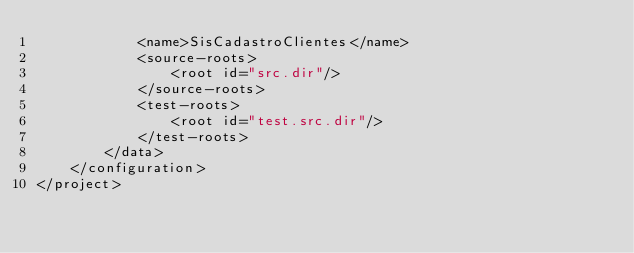Convert code to text. <code><loc_0><loc_0><loc_500><loc_500><_XML_>            <name>SisCadastroClientes</name>
            <source-roots>
                <root id="src.dir"/>
            </source-roots>
            <test-roots>
                <root id="test.src.dir"/>
            </test-roots>
        </data>
    </configuration>
</project>
</code> 